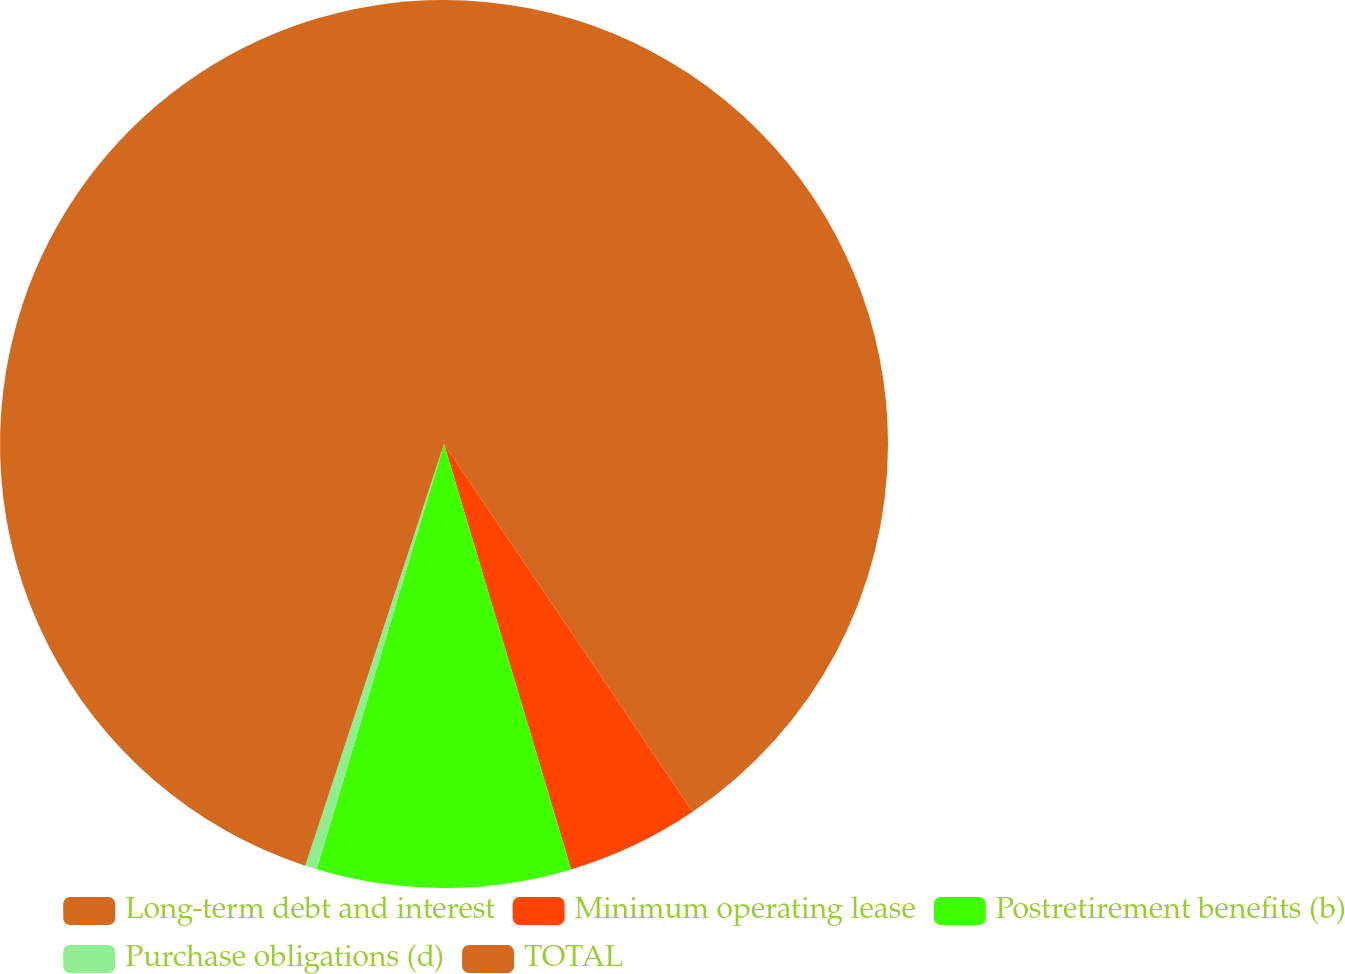<chart> <loc_0><loc_0><loc_500><loc_500><pie_chart><fcel>Long-term debt and interest<fcel>Minimum operating lease<fcel>Postretirement benefits (b)<fcel>Purchase obligations (d)<fcel>TOTAL<nl><fcel>40.54%<fcel>4.84%<fcel>9.25%<fcel>0.43%<fcel>44.94%<nl></chart> 